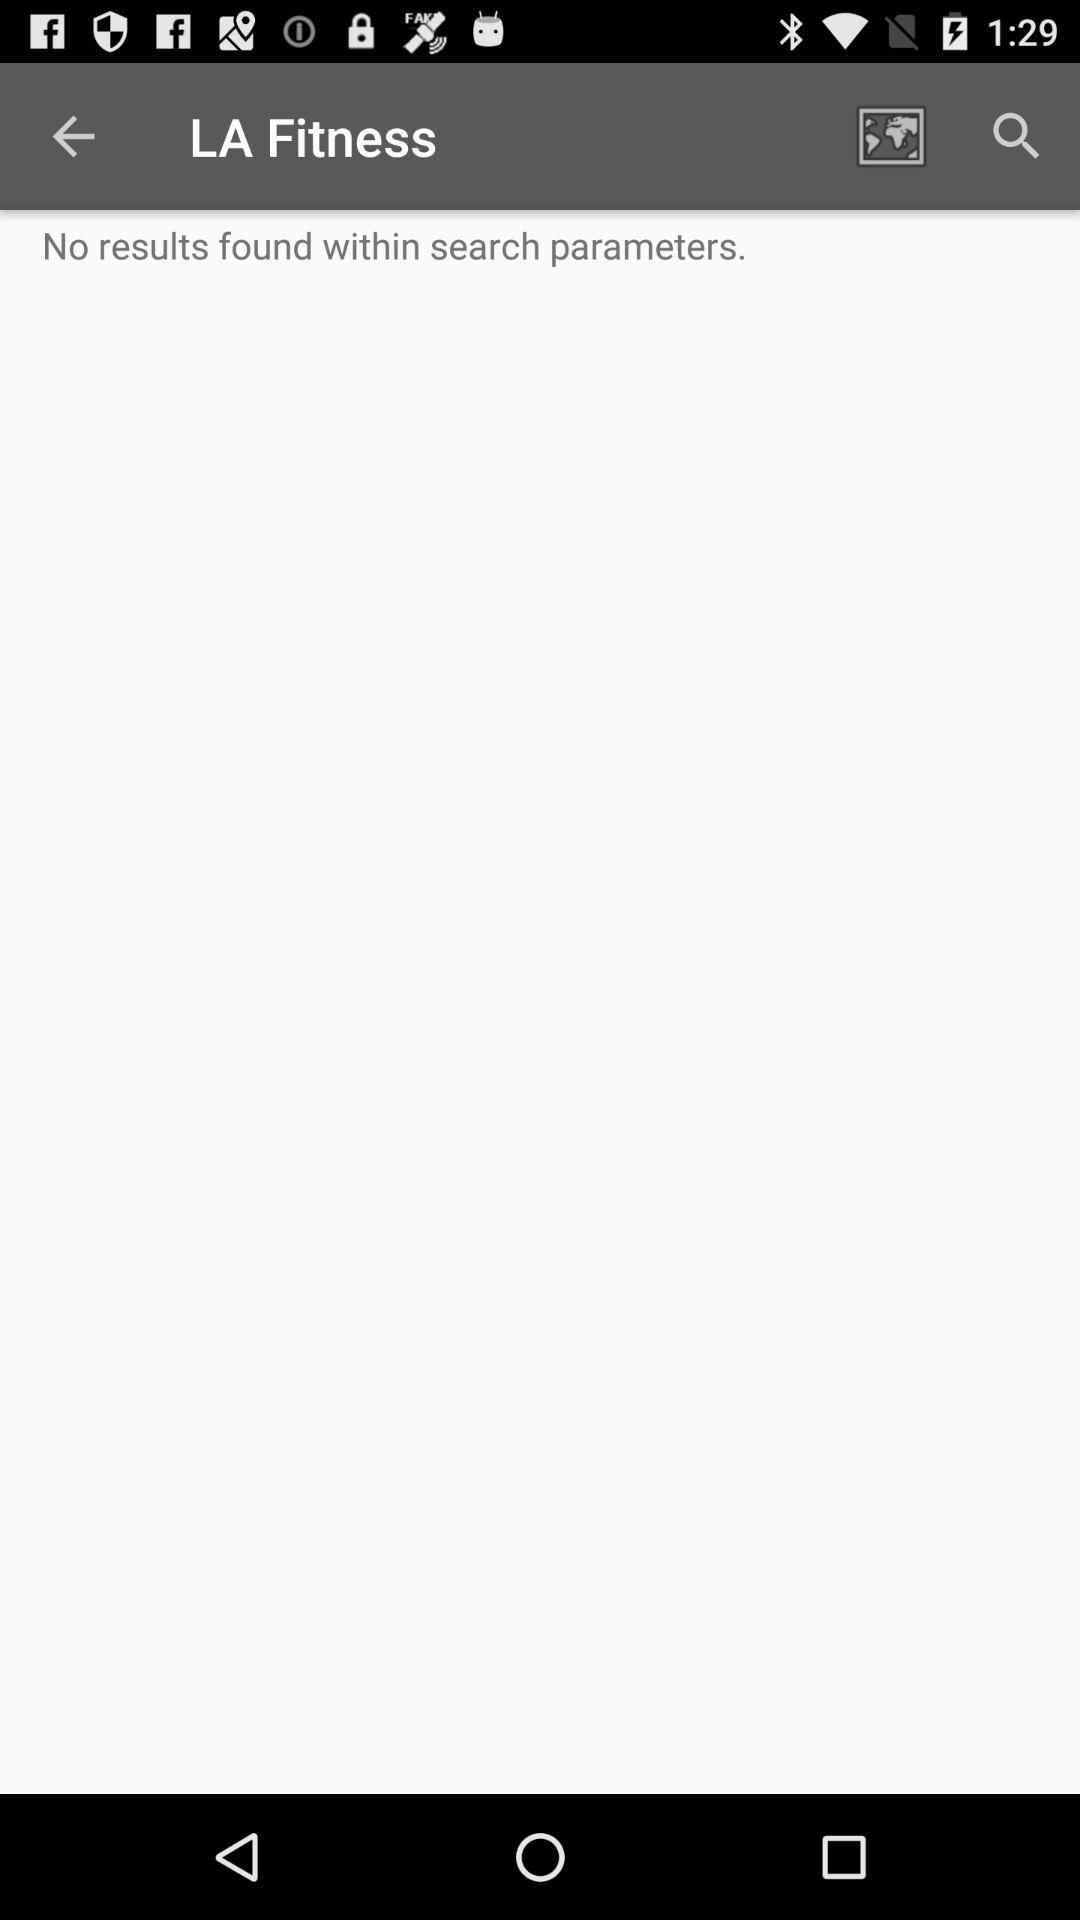What is the application name? The application name is "LA Fitness". 